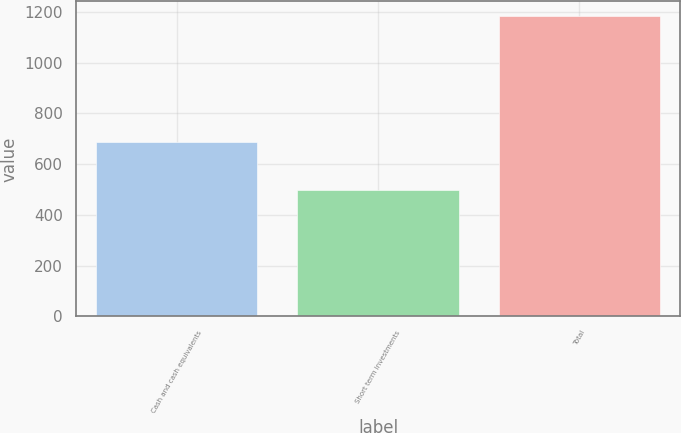Convert chart. <chart><loc_0><loc_0><loc_500><loc_500><bar_chart><fcel>Cash and cash equivalents<fcel>Short term investments<fcel>Total<nl><fcel>686<fcel>497<fcel>1183<nl></chart> 